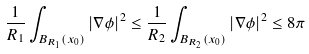<formula> <loc_0><loc_0><loc_500><loc_500>\frac { 1 } { R _ { 1 } } \int _ { B _ { R _ { 1 } } ( x _ { 0 } ) } | \nabla \phi | ^ { 2 } \leq \frac { 1 } { R _ { 2 } } \int _ { B _ { R _ { 2 } } ( x _ { 0 } ) } | \nabla \phi | ^ { 2 } \leq 8 \pi</formula> 